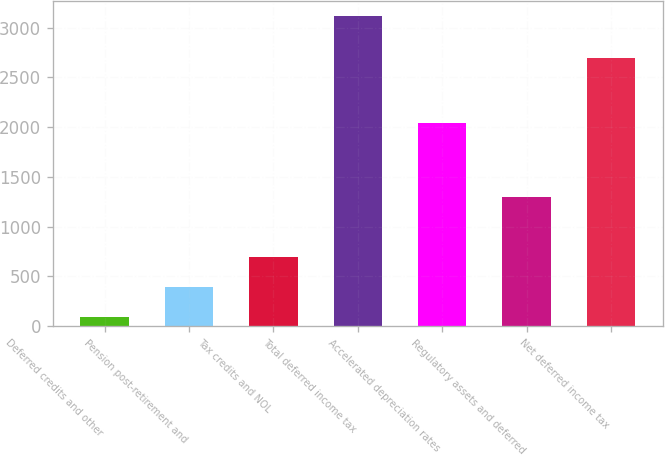Convert chart. <chart><loc_0><loc_0><loc_500><loc_500><bar_chart><fcel>Deferred credits and other<fcel>Pension post-retirement and<fcel>Tax credits and NOL<fcel>Total deferred income tax<fcel>Accelerated depreciation rates<fcel>Regulatory assets and deferred<fcel>Net deferred income tax<nl><fcel>93<fcel>395.2<fcel>697.4<fcel>3115<fcel>2038<fcel>1301.8<fcel>2694<nl></chart> 